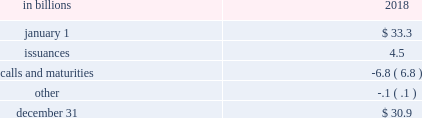The pnc financial services group , inc .
2013 form 10-k 65 liquidity and capital management liquidity risk has two fundamental components .
The first is potential loss assuming we were unable to meet our funding requirements at a reasonable cost .
The second is the potential inability to operate our businesses because adequate contingent liquidity is not available .
We manage liquidity risk at the consolidated company level ( bank , parent company and nonbank subsidiaries combined ) to help ensure that we can obtain cost-effective funding to meet current and future obligations under both normal 201cbusiness as usual 201d and stressful circumstances , and to help ensure that we maintain an appropriate level of contingent liquidity .
Management monitors liquidity through a series of early warning indicators that may indicate a potential market , or pnc-specific , liquidity stress event .
In addition , management performs a set of liquidity stress tests over multiple time horizons with varying levels of severity and maintains a contingency funding plan to address a potential liquidity stress event .
In the most severe liquidity stress simulation , we assume that our liquidity position is under pressure , while the market in general is under systemic pressure .
The simulation considers , among other things , the impact of restricted access to both secured and unsecured external sources of funding , accelerated run-off of customer deposits , valuation pressure on assets and heavy demand to fund committed obligations .
Parent company liquidity guidelines are designed to help ensure that sufficient liquidity is available to meet our parent company obligations over the succeeding 24-month period .
Liquidity-related risk limits are established within our enterprise liquidity management policy and supporting policies .
Management committees , including the asset and liability committee , and the board of directors and its risk committee regularly review compliance with key established limits .
In addition to these liquidity monitoring measures and tools described above , we also monitor our liquidity by reference to the liquidity coverage ratio ( lcr ) which is further described in the supervision and regulation section in item 1 of this report .
Pnc and pnc bank calculate the lcr on a daily basis and as of december 31 , 2018 , the lcr for pnc and pnc bank exceeded the fully phased-in requirement of 100% ( 100 % ) .
We provide additional information regarding regulatory liquidity requirements and their potential impact on us in the supervision and regulation section of item 1 business and item 1a risk factors of this report .
Sources of liquidity our largest source of liquidity on a consolidated basis is the customer deposit base generated by our banking businesses .
These deposits provide relatively stable and low-cost funding .
Total deposits increased to $ 267.8 billion at december 31 , 2018 from $ 265.1 billion at december 31 , 2017 driven by growth in interest-bearing deposits partially offset by a decrease in noninterest-bearing deposits .
See the funding sources section of the consolidated balance sheet review in this report for additional information related to our deposits .
Additionally , certain assets determined by us to be liquid as well as unused borrowing capacity from a number of sources are also available to manage our liquidity position .
At december 31 , 2018 , our liquid assets consisted of short-term investments ( federal funds sold , resale agreements , trading securities and interest-earning deposits with banks ) totaling $ 22.1 billion and securities available for sale totaling $ 63.4 billion .
The level of liquid assets fluctuates over time based on many factors , including market conditions , loan and deposit growth and balance sheet management activities .
Our liquid assets included $ 2.7 billion of securities available for sale and trading securities pledged as collateral to secure public and trust deposits , repurchase agreements and for other purposes .
In addition , $ 4.9 billion of securities held to maturity were also pledged as collateral for these purposes .
We also obtain liquidity through various forms of funding , including long-term debt ( senior notes , subordinated debt and fhlb borrowings ) and short-term borrowings ( securities sold under repurchase agreements , commercial paper and other short-term borrowings ) .
See note 10 borrowed funds and the funding sources section of the consolidated balance sheet review in this report for additional information related to our borrowings .
Total senior and subordinated debt , on a consolidated basis , decreased due to the following activity : table 24 : senior and subordinated debt .

Assuming all matured securities were pledged as collateral , how much should we assume came from the calls? 
Computations: (6.8 - 4.9)
Answer: 1.9. 